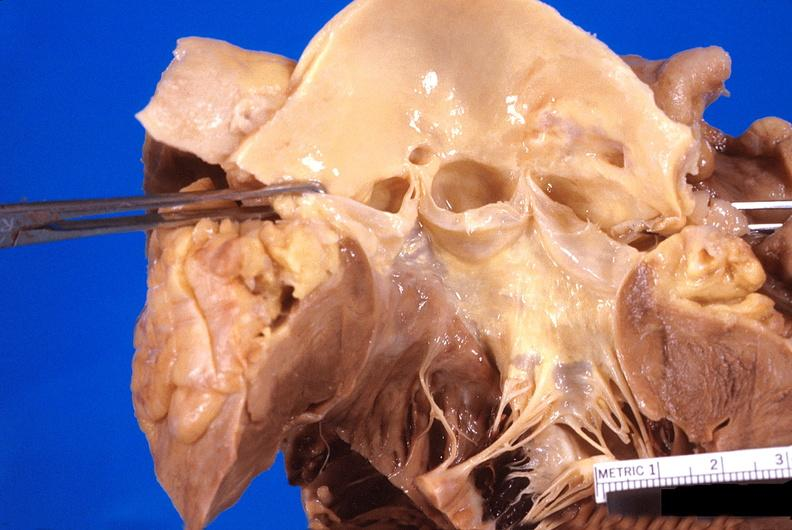does this image show abnormal location of coronary artery ostia?
Answer the question using a single word or phrase. Yes 